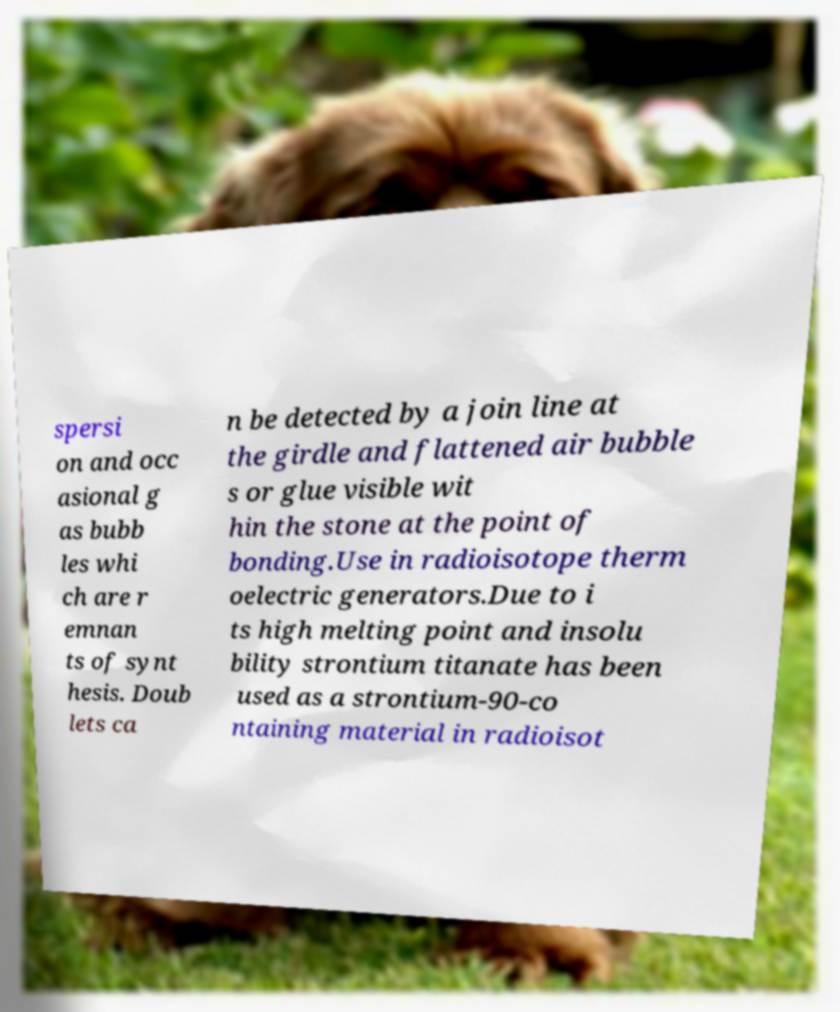Could you extract and type out the text from this image? spersi on and occ asional g as bubb les whi ch are r emnan ts of synt hesis. Doub lets ca n be detected by a join line at the girdle and flattened air bubble s or glue visible wit hin the stone at the point of bonding.Use in radioisotope therm oelectric generators.Due to i ts high melting point and insolu bility strontium titanate has been used as a strontium-90-co ntaining material in radioisot 